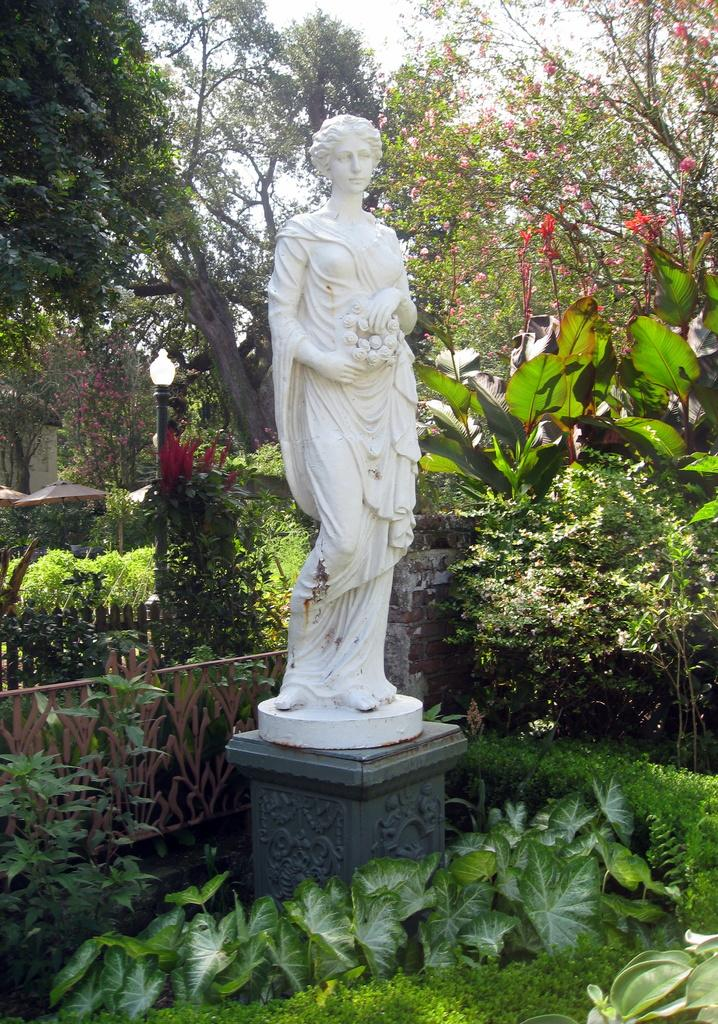What is the main subject of the image? There is a white color statue in the image. What type of vegetation can be seen in the image? There are trees in the image. What color are the flowers in the image? There are red color flowers in the image. What type of barrier is present in the image? There is fencing in the image. What type of structure is visible in the image? There is a light-pole in the image. What color is the sky in the image? The sky is white in color. What type of bottle is being used for the voyage in the image? There is no bottle or voyage present in the image. What type of bread is being served at the event in the image? There is no event or bread present in the image. 